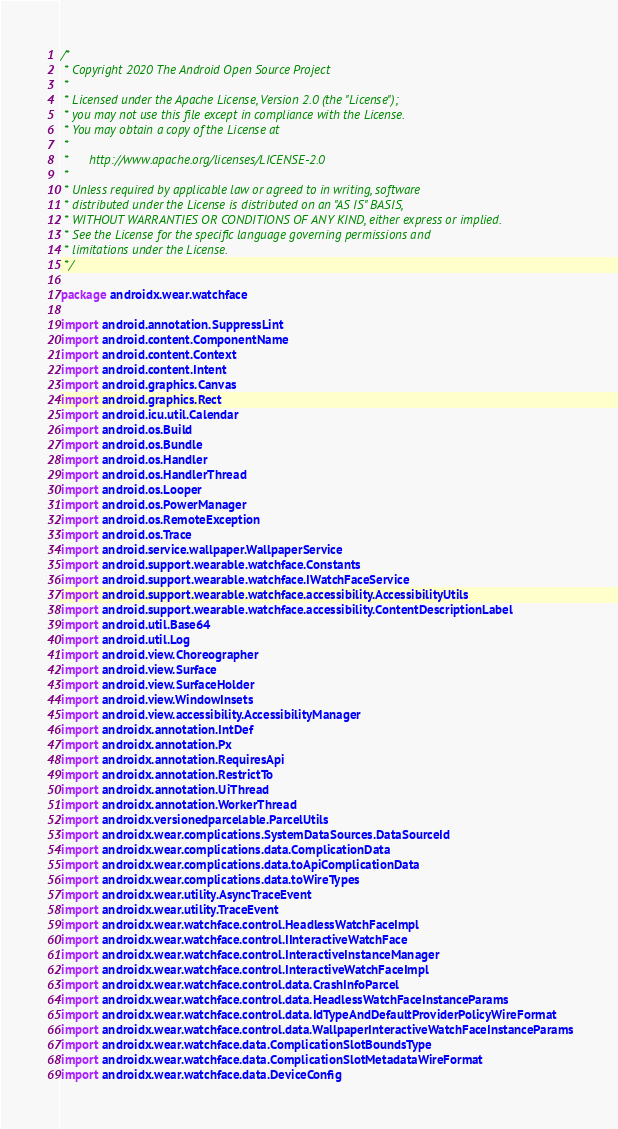Convert code to text. <code><loc_0><loc_0><loc_500><loc_500><_Kotlin_>/*
 * Copyright 2020 The Android Open Source Project
 *
 * Licensed under the Apache License, Version 2.0 (the "License");
 * you may not use this file except in compliance with the License.
 * You may obtain a copy of the License at
 *
 *      http://www.apache.org/licenses/LICENSE-2.0
 *
 * Unless required by applicable law or agreed to in writing, software
 * distributed under the License is distributed on an "AS IS" BASIS,
 * WITHOUT WARRANTIES OR CONDITIONS OF ANY KIND, either express or implied.
 * See the License for the specific language governing permissions and
 * limitations under the License.
 */

package androidx.wear.watchface

import android.annotation.SuppressLint
import android.content.ComponentName
import android.content.Context
import android.content.Intent
import android.graphics.Canvas
import android.graphics.Rect
import android.icu.util.Calendar
import android.os.Build
import android.os.Bundle
import android.os.Handler
import android.os.HandlerThread
import android.os.Looper
import android.os.PowerManager
import android.os.RemoteException
import android.os.Trace
import android.service.wallpaper.WallpaperService
import android.support.wearable.watchface.Constants
import android.support.wearable.watchface.IWatchFaceService
import android.support.wearable.watchface.accessibility.AccessibilityUtils
import android.support.wearable.watchface.accessibility.ContentDescriptionLabel
import android.util.Base64
import android.util.Log
import android.view.Choreographer
import android.view.Surface
import android.view.SurfaceHolder
import android.view.WindowInsets
import android.view.accessibility.AccessibilityManager
import androidx.annotation.IntDef
import androidx.annotation.Px
import androidx.annotation.RequiresApi
import androidx.annotation.RestrictTo
import androidx.annotation.UiThread
import androidx.annotation.WorkerThread
import androidx.versionedparcelable.ParcelUtils
import androidx.wear.complications.SystemDataSources.DataSourceId
import androidx.wear.complications.data.ComplicationData
import androidx.wear.complications.data.toApiComplicationData
import androidx.wear.complications.data.toWireTypes
import androidx.wear.utility.AsyncTraceEvent
import androidx.wear.utility.TraceEvent
import androidx.wear.watchface.control.HeadlessWatchFaceImpl
import androidx.wear.watchface.control.IInteractiveWatchFace
import androidx.wear.watchface.control.InteractiveInstanceManager
import androidx.wear.watchface.control.InteractiveWatchFaceImpl
import androidx.wear.watchface.control.data.CrashInfoParcel
import androidx.wear.watchface.control.data.HeadlessWatchFaceInstanceParams
import androidx.wear.watchface.control.data.IdTypeAndDefaultProviderPolicyWireFormat
import androidx.wear.watchface.control.data.WallpaperInteractiveWatchFaceInstanceParams
import androidx.wear.watchface.data.ComplicationSlotBoundsType
import androidx.wear.watchface.data.ComplicationSlotMetadataWireFormat
import androidx.wear.watchface.data.DeviceConfig</code> 